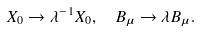<formula> <loc_0><loc_0><loc_500><loc_500>X _ { 0 } \rightarrow \lambda ^ { - 1 } X _ { 0 } , \ \ B _ { \mu } \rightarrow \lambda B _ { \mu } .</formula> 